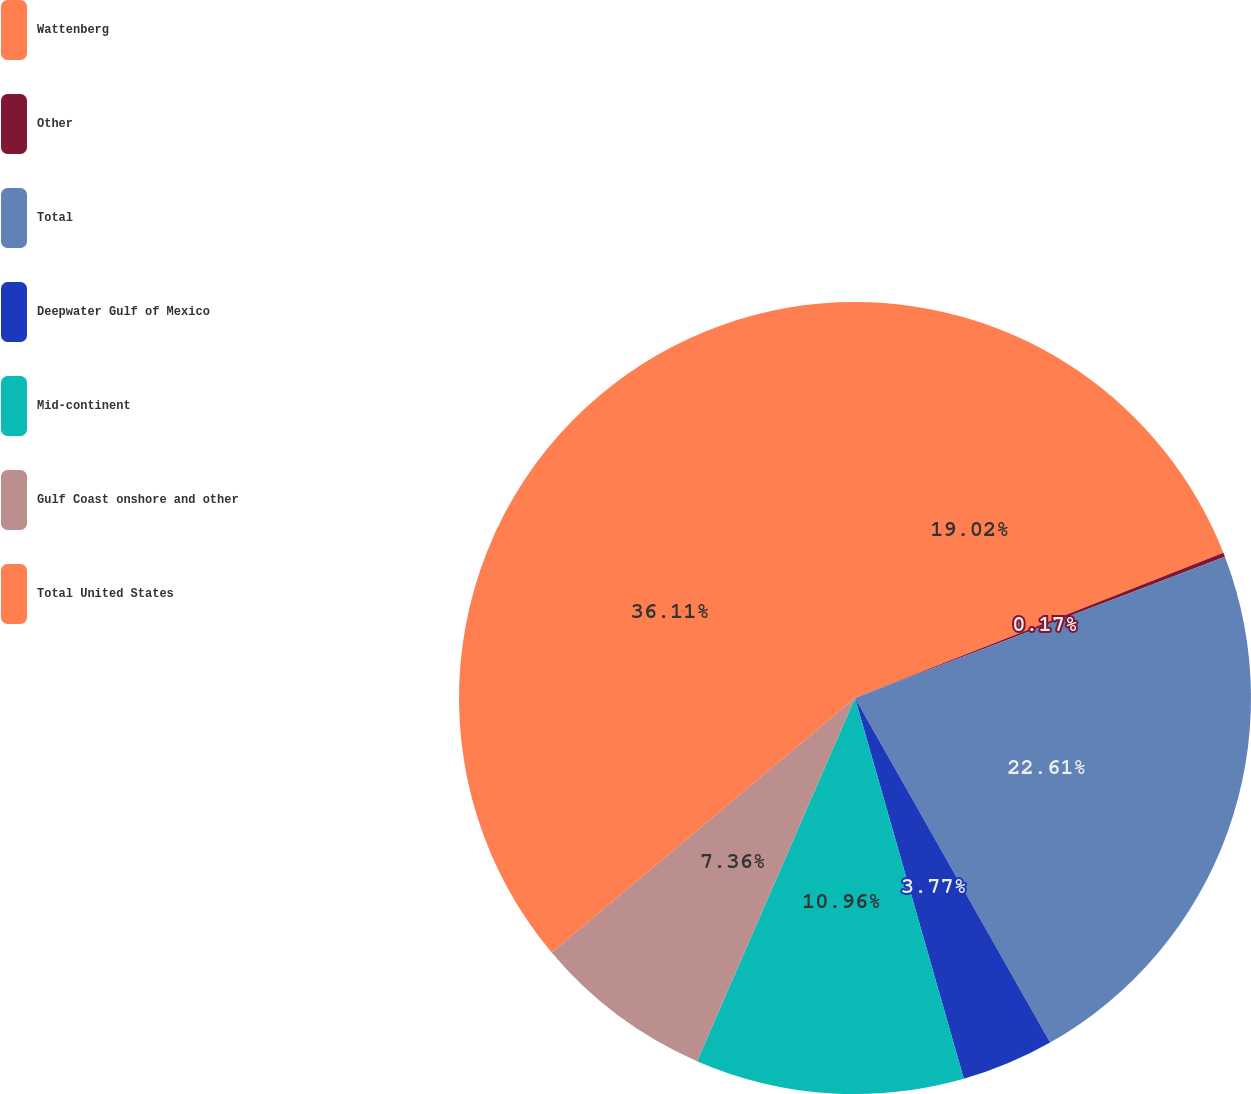Convert chart to OTSL. <chart><loc_0><loc_0><loc_500><loc_500><pie_chart><fcel>Wattenberg<fcel>Other<fcel>Total<fcel>Deepwater Gulf of Mexico<fcel>Mid-continent<fcel>Gulf Coast onshore and other<fcel>Total United States<nl><fcel>19.02%<fcel>0.17%<fcel>22.61%<fcel>3.77%<fcel>10.96%<fcel>7.36%<fcel>36.11%<nl></chart> 